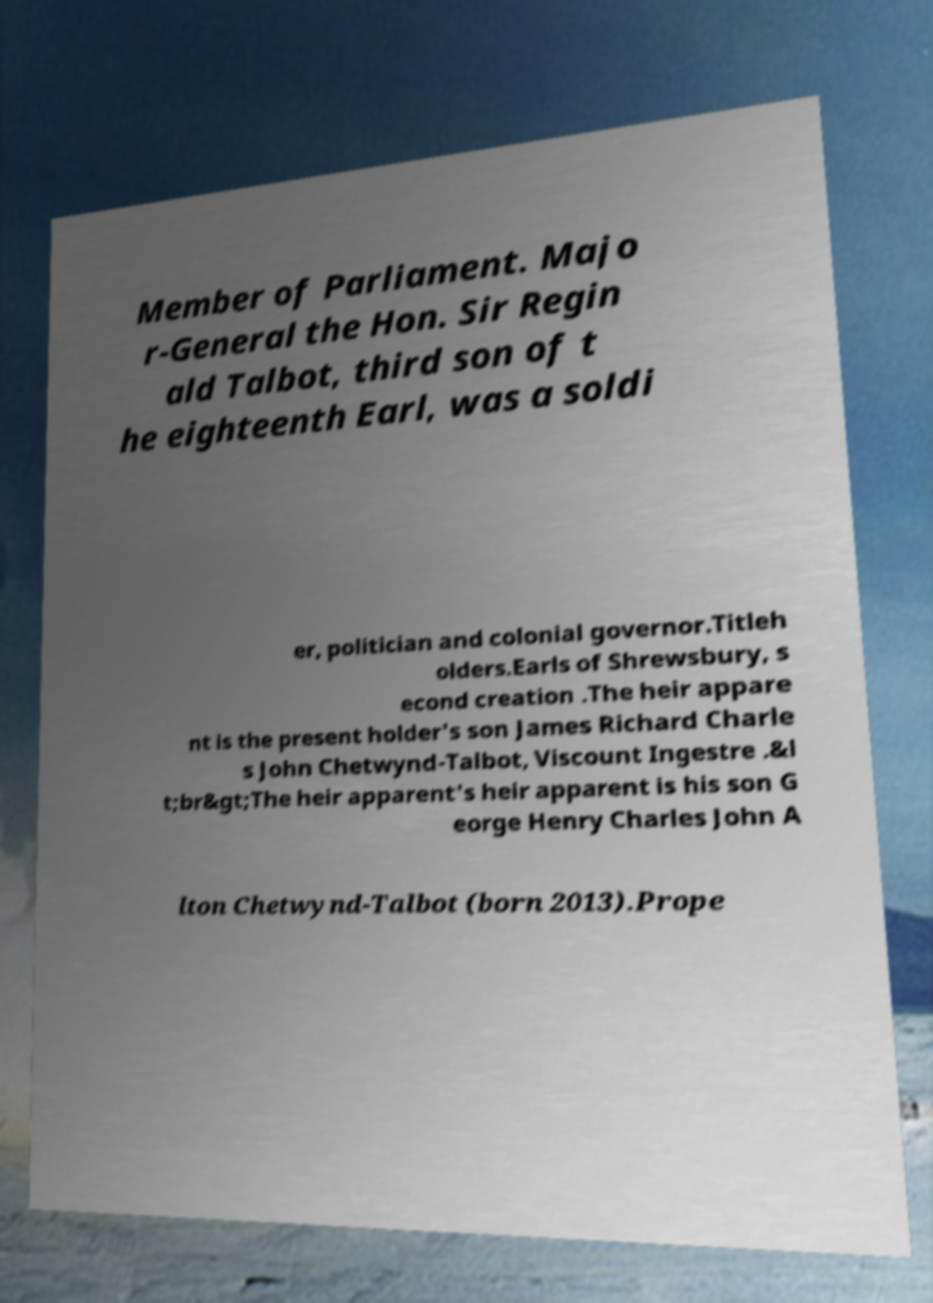What messages or text are displayed in this image? I need them in a readable, typed format. Member of Parliament. Majo r-General the Hon. Sir Regin ald Talbot, third son of t he eighteenth Earl, was a soldi er, politician and colonial governor.Titleh olders.Earls of Shrewsbury, s econd creation .The heir appare nt is the present holder's son James Richard Charle s John Chetwynd-Talbot, Viscount Ingestre .&l t;br&gt;The heir apparent's heir apparent is his son G eorge Henry Charles John A lton Chetwynd-Talbot (born 2013).Prope 